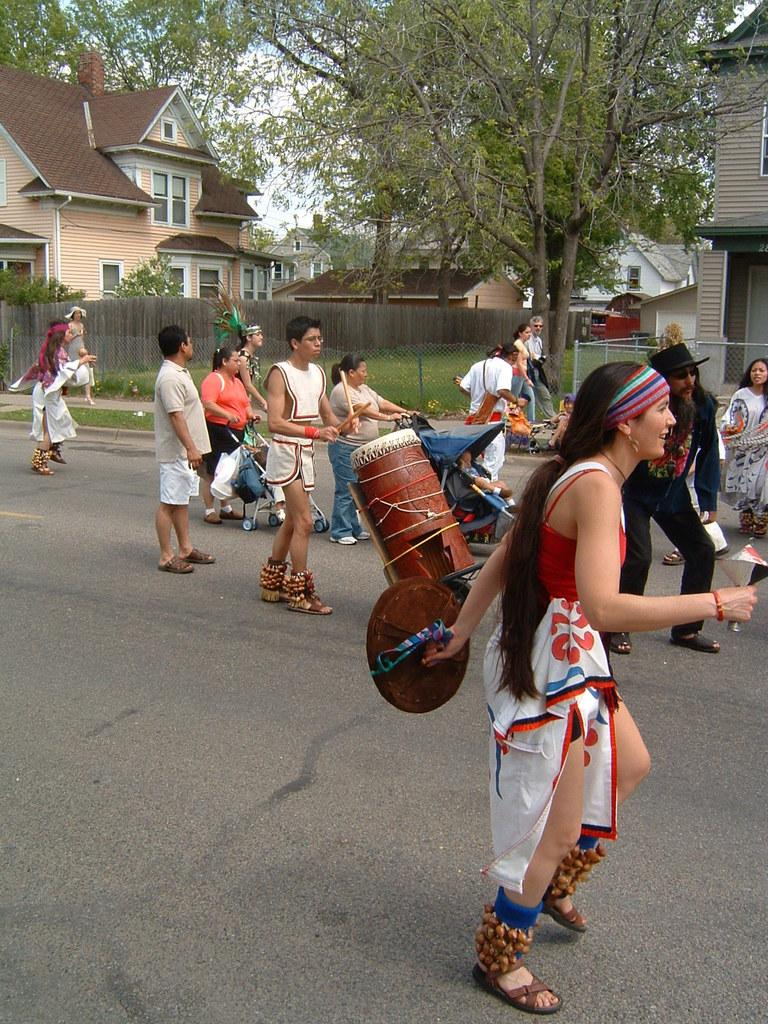What is happening on the road in the image? There are many people on the road in the image. Can you identify any specific activities that people are engaged in? Yes, two people are playing instruments. What type of structures can be seen in the image? There are buildings in the image. What other natural elements are present in the image? There are trees in the image. How would you describe the weather based on the image? The sky is clear in the image, suggesting good weather. What type of pen is being used by the person on the left side of the image? There is no person using a pen in the image; it features people on the road and two individuals playing instruments. What type of store can be seen in the image? There is no store present in the image; it primarily shows people on the road, buildings, and trees. 